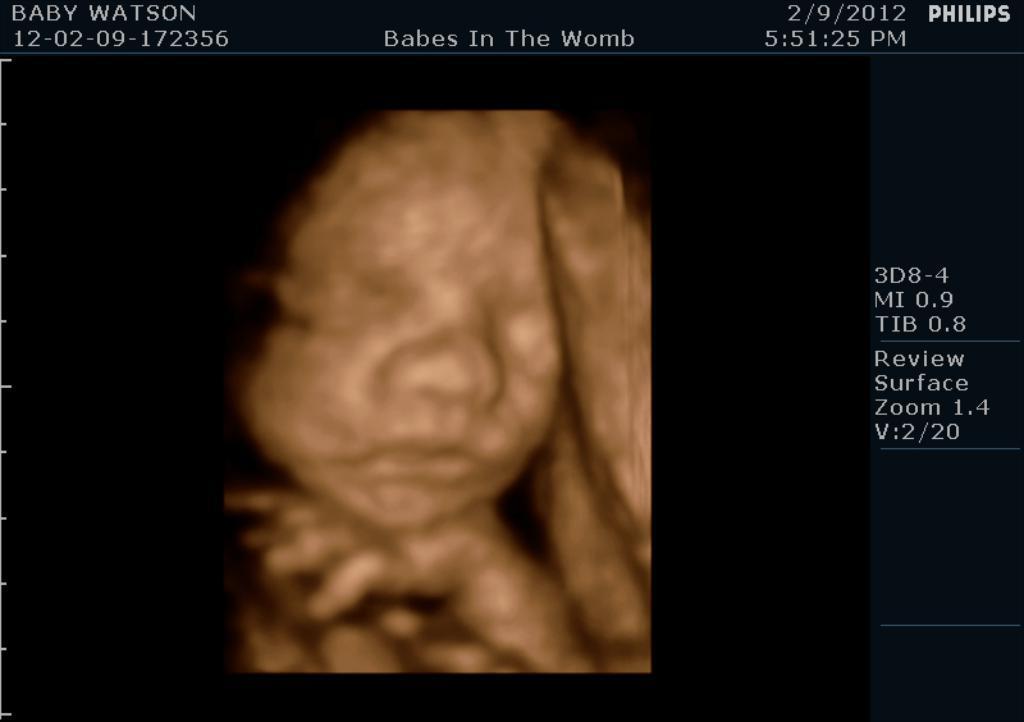How would you summarize this image in a sentence or two? In this picture we can see a screen and on this screen we can see a baby and some text. 